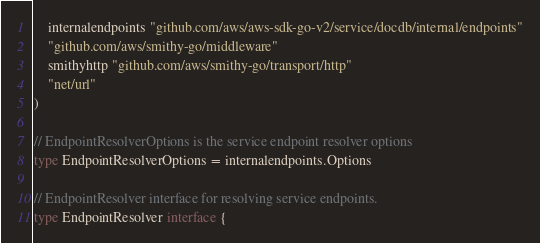<code> <loc_0><loc_0><loc_500><loc_500><_Go_>	internalendpoints "github.com/aws/aws-sdk-go-v2/service/docdb/internal/endpoints"
	"github.com/aws/smithy-go/middleware"
	smithyhttp "github.com/aws/smithy-go/transport/http"
	"net/url"
)

// EndpointResolverOptions is the service endpoint resolver options
type EndpointResolverOptions = internalendpoints.Options

// EndpointResolver interface for resolving service endpoints.
type EndpointResolver interface {</code> 